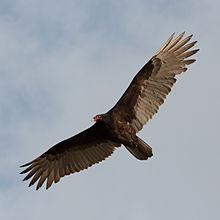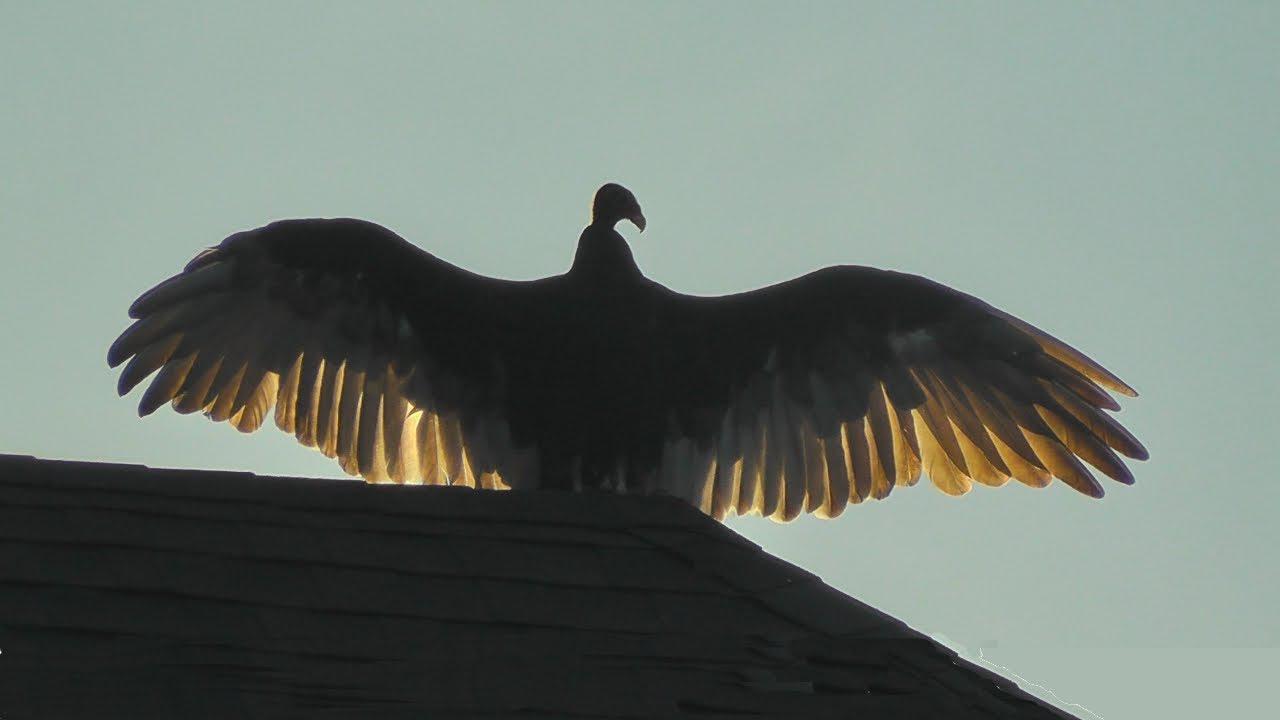The first image is the image on the left, the second image is the image on the right. For the images displayed, is the sentence "Two large birds have their wings extended, one in the air and one sitting." factually correct? Answer yes or no. Yes. The first image is the image on the left, the second image is the image on the right. For the images shown, is this caption "An image shows one vulture perched on something, with its wings spread horizontally." true? Answer yes or no. Yes. 